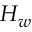Convert formula to latex. <formula><loc_0><loc_0><loc_500><loc_500>H _ { w }</formula> 